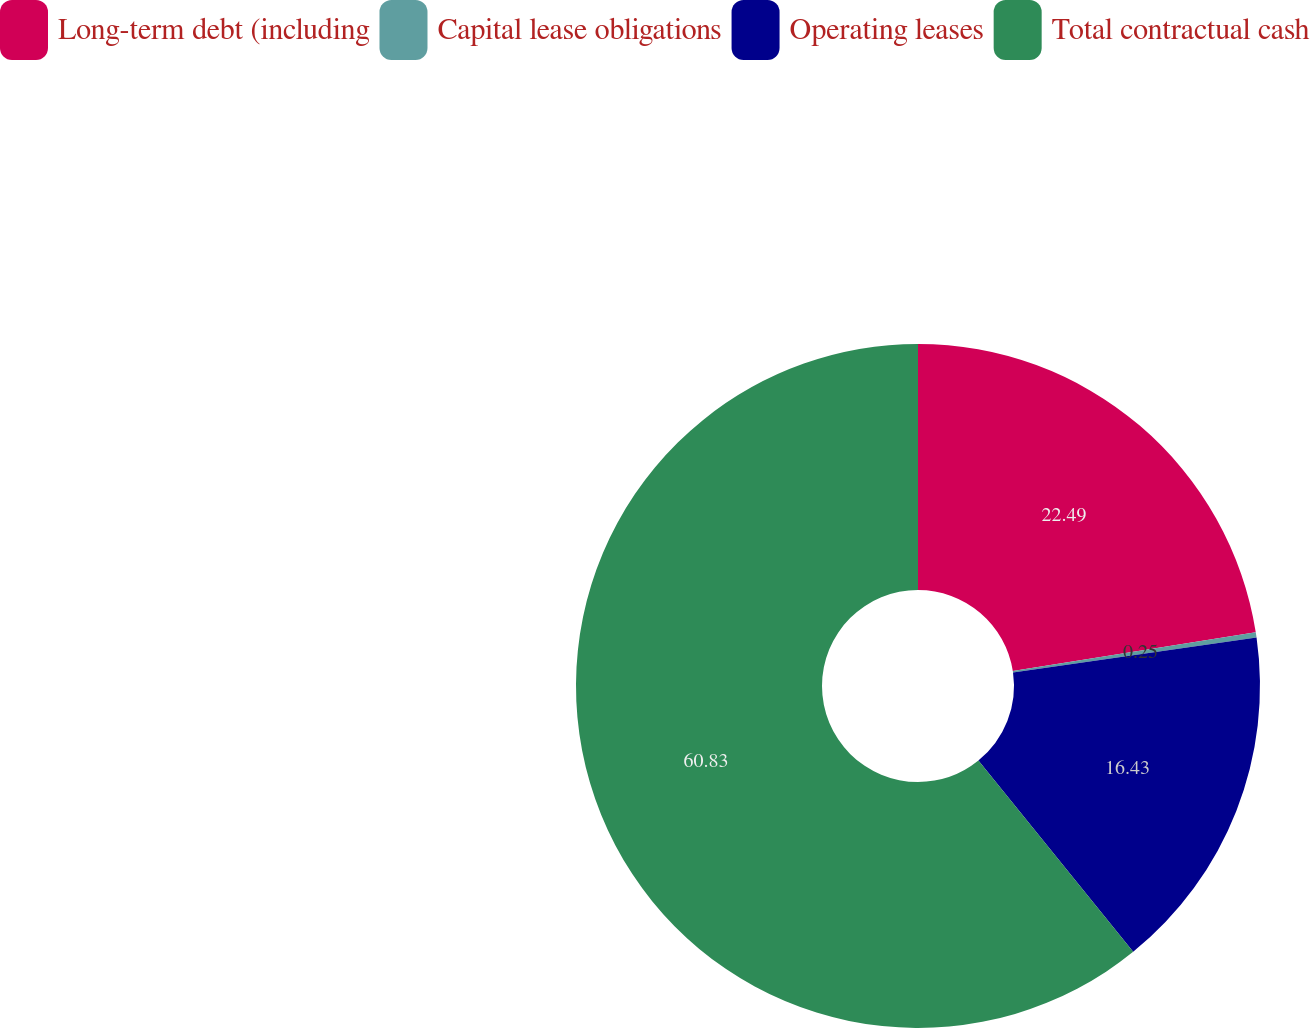Convert chart. <chart><loc_0><loc_0><loc_500><loc_500><pie_chart><fcel>Long-term debt (including<fcel>Capital lease obligations<fcel>Operating leases<fcel>Total contractual cash<nl><fcel>22.49%<fcel>0.25%<fcel>16.43%<fcel>60.83%<nl></chart> 